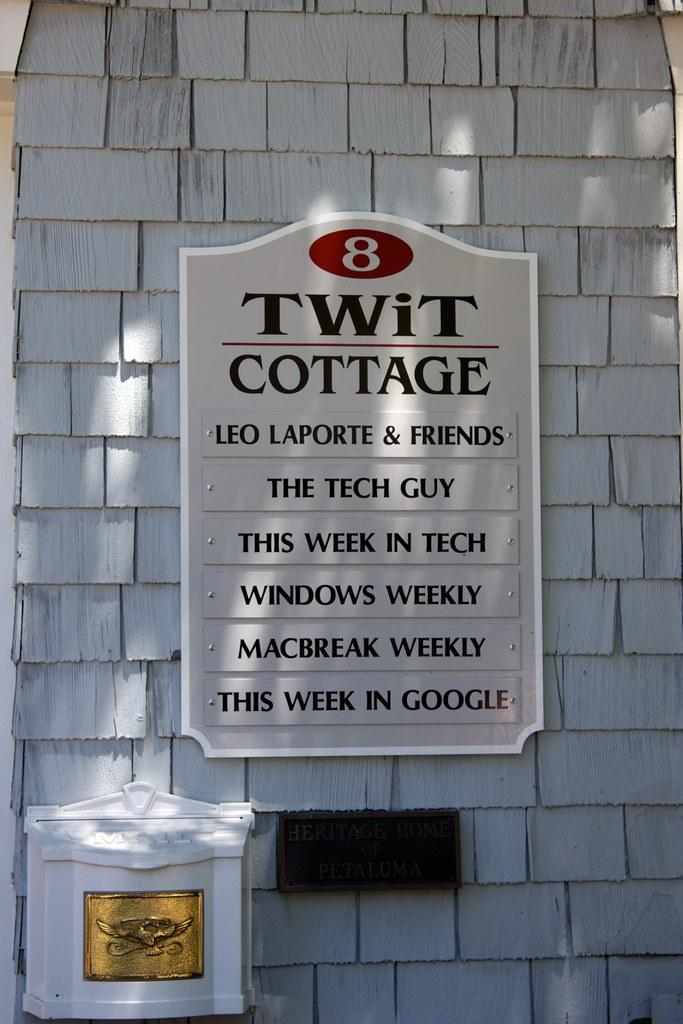What objects are attached to the wall in the image? There are two boards attached to a wall in the image. What can be seen on one of the boards? There is text on one of the boards in the middle of the image. Where is the pail located in the image? There is no pail present in the image. What type of jail is depicted on one of the boards? There is no jail depicted on the boards; only text is present. 